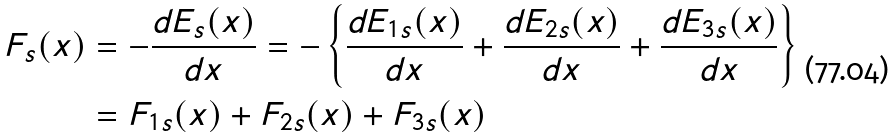<formula> <loc_0><loc_0><loc_500><loc_500>F _ { s } ( x ) & = - \frac { d E _ { s } ( x ) } { d x } = - \left \{ \frac { d E _ { 1 s } ( x ) } { d x } + \frac { d E _ { 2 s } ( x ) } { d x } + \frac { d E _ { 3 s } ( x ) } { d x } \right \} \\ & = F _ { 1 s } ( x ) + F _ { 2 s } ( x ) + F _ { 3 s } ( x )</formula> 